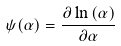Convert formula to latex. <formula><loc_0><loc_0><loc_500><loc_500>\psi ( \alpha ) = \frac { \partial \ln \Gamma ( \alpha ) } { \partial \alpha }</formula> 